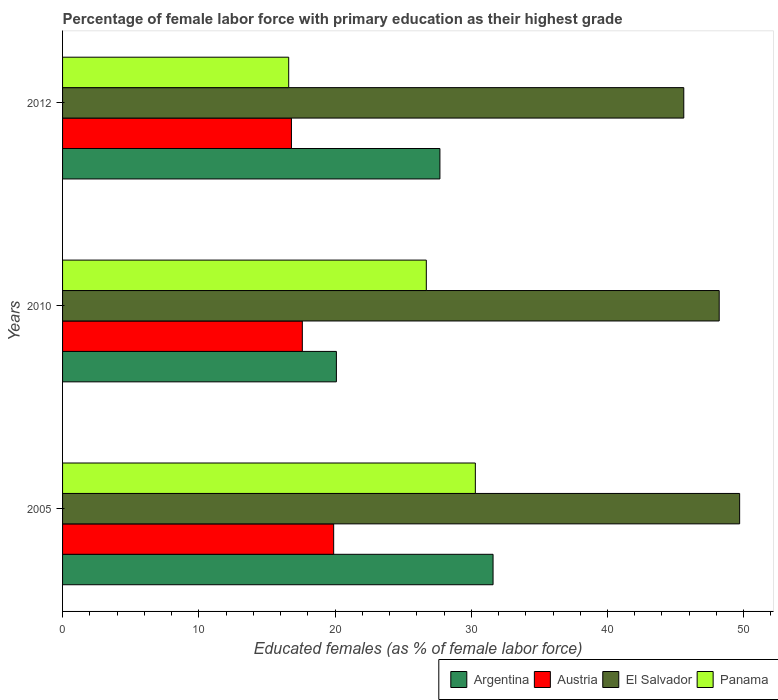How many different coloured bars are there?
Offer a terse response. 4. How many groups of bars are there?
Give a very brief answer. 3. Are the number of bars on each tick of the Y-axis equal?
Offer a terse response. Yes. How many bars are there on the 2nd tick from the top?
Ensure brevity in your answer.  4. What is the percentage of female labor force with primary education in Austria in 2012?
Offer a terse response. 16.8. Across all years, what is the maximum percentage of female labor force with primary education in Argentina?
Give a very brief answer. 31.6. Across all years, what is the minimum percentage of female labor force with primary education in Austria?
Make the answer very short. 16.8. In which year was the percentage of female labor force with primary education in Argentina minimum?
Provide a short and direct response. 2010. What is the total percentage of female labor force with primary education in Panama in the graph?
Provide a short and direct response. 73.6. What is the difference between the percentage of female labor force with primary education in Argentina in 2010 and that in 2012?
Offer a terse response. -7.6. What is the difference between the percentage of female labor force with primary education in Austria in 2010 and the percentage of female labor force with primary education in Panama in 2005?
Your answer should be very brief. -12.7. What is the average percentage of female labor force with primary education in Panama per year?
Give a very brief answer. 24.53. In the year 2012, what is the difference between the percentage of female labor force with primary education in El Salvador and percentage of female labor force with primary education in Austria?
Your answer should be compact. 28.8. What is the ratio of the percentage of female labor force with primary education in Panama in 2005 to that in 2012?
Your response must be concise. 1.83. What is the difference between the highest and the second highest percentage of female labor force with primary education in Austria?
Your response must be concise. 2.3. What is the difference between the highest and the lowest percentage of female labor force with primary education in El Salvador?
Keep it short and to the point. 4.1. Is the sum of the percentage of female labor force with primary education in El Salvador in 2005 and 2010 greater than the maximum percentage of female labor force with primary education in Argentina across all years?
Your answer should be compact. Yes. Is it the case that in every year, the sum of the percentage of female labor force with primary education in Argentina and percentage of female labor force with primary education in El Salvador is greater than the sum of percentage of female labor force with primary education in Austria and percentage of female labor force with primary education in Panama?
Provide a short and direct response. Yes. What does the 4th bar from the bottom in 2005 represents?
Provide a short and direct response. Panama. How many bars are there?
Your answer should be very brief. 12. Are all the bars in the graph horizontal?
Make the answer very short. Yes. Are the values on the major ticks of X-axis written in scientific E-notation?
Keep it short and to the point. No. Does the graph contain grids?
Give a very brief answer. No. How are the legend labels stacked?
Provide a succinct answer. Horizontal. What is the title of the graph?
Your response must be concise. Percentage of female labor force with primary education as their highest grade. Does "Fragile and conflict affected situations" appear as one of the legend labels in the graph?
Your answer should be very brief. No. What is the label or title of the X-axis?
Make the answer very short. Educated females (as % of female labor force). What is the label or title of the Y-axis?
Provide a short and direct response. Years. What is the Educated females (as % of female labor force) of Argentina in 2005?
Keep it short and to the point. 31.6. What is the Educated females (as % of female labor force) in Austria in 2005?
Provide a short and direct response. 19.9. What is the Educated females (as % of female labor force) in El Salvador in 2005?
Ensure brevity in your answer.  49.7. What is the Educated females (as % of female labor force) in Panama in 2005?
Give a very brief answer. 30.3. What is the Educated females (as % of female labor force) in Argentina in 2010?
Offer a terse response. 20.1. What is the Educated females (as % of female labor force) in Austria in 2010?
Your answer should be compact. 17.6. What is the Educated females (as % of female labor force) in El Salvador in 2010?
Provide a succinct answer. 48.2. What is the Educated females (as % of female labor force) in Panama in 2010?
Provide a short and direct response. 26.7. What is the Educated females (as % of female labor force) in Argentina in 2012?
Make the answer very short. 27.7. What is the Educated females (as % of female labor force) of Austria in 2012?
Offer a terse response. 16.8. What is the Educated females (as % of female labor force) of El Salvador in 2012?
Make the answer very short. 45.6. What is the Educated females (as % of female labor force) in Panama in 2012?
Your answer should be compact. 16.6. Across all years, what is the maximum Educated females (as % of female labor force) in Argentina?
Your response must be concise. 31.6. Across all years, what is the maximum Educated females (as % of female labor force) in Austria?
Offer a terse response. 19.9. Across all years, what is the maximum Educated females (as % of female labor force) of El Salvador?
Ensure brevity in your answer.  49.7. Across all years, what is the maximum Educated females (as % of female labor force) in Panama?
Offer a terse response. 30.3. Across all years, what is the minimum Educated females (as % of female labor force) of Argentina?
Keep it short and to the point. 20.1. Across all years, what is the minimum Educated females (as % of female labor force) in Austria?
Your response must be concise. 16.8. Across all years, what is the minimum Educated females (as % of female labor force) of El Salvador?
Give a very brief answer. 45.6. Across all years, what is the minimum Educated females (as % of female labor force) of Panama?
Offer a terse response. 16.6. What is the total Educated females (as % of female labor force) in Argentina in the graph?
Make the answer very short. 79.4. What is the total Educated females (as % of female labor force) of Austria in the graph?
Keep it short and to the point. 54.3. What is the total Educated females (as % of female labor force) in El Salvador in the graph?
Make the answer very short. 143.5. What is the total Educated females (as % of female labor force) of Panama in the graph?
Your answer should be very brief. 73.6. What is the difference between the Educated females (as % of female labor force) in Austria in 2005 and that in 2010?
Give a very brief answer. 2.3. What is the difference between the Educated females (as % of female labor force) in Argentina in 2005 and that in 2012?
Give a very brief answer. 3.9. What is the difference between the Educated females (as % of female labor force) of Austria in 2005 and that in 2012?
Offer a terse response. 3.1. What is the difference between the Educated females (as % of female labor force) in El Salvador in 2005 and that in 2012?
Offer a terse response. 4.1. What is the difference between the Educated females (as % of female labor force) of Panama in 2005 and that in 2012?
Ensure brevity in your answer.  13.7. What is the difference between the Educated females (as % of female labor force) in El Salvador in 2010 and that in 2012?
Keep it short and to the point. 2.6. What is the difference between the Educated females (as % of female labor force) of Panama in 2010 and that in 2012?
Make the answer very short. 10.1. What is the difference between the Educated females (as % of female labor force) of Argentina in 2005 and the Educated females (as % of female labor force) of Austria in 2010?
Ensure brevity in your answer.  14. What is the difference between the Educated females (as % of female labor force) in Argentina in 2005 and the Educated females (as % of female labor force) in El Salvador in 2010?
Offer a terse response. -16.6. What is the difference between the Educated females (as % of female labor force) of Argentina in 2005 and the Educated females (as % of female labor force) of Panama in 2010?
Your answer should be compact. 4.9. What is the difference between the Educated females (as % of female labor force) of Austria in 2005 and the Educated females (as % of female labor force) of El Salvador in 2010?
Provide a short and direct response. -28.3. What is the difference between the Educated females (as % of female labor force) in Austria in 2005 and the Educated females (as % of female labor force) in Panama in 2010?
Offer a terse response. -6.8. What is the difference between the Educated females (as % of female labor force) of Argentina in 2005 and the Educated females (as % of female labor force) of Austria in 2012?
Give a very brief answer. 14.8. What is the difference between the Educated females (as % of female labor force) in Argentina in 2005 and the Educated females (as % of female labor force) in El Salvador in 2012?
Make the answer very short. -14. What is the difference between the Educated females (as % of female labor force) in Austria in 2005 and the Educated females (as % of female labor force) in El Salvador in 2012?
Keep it short and to the point. -25.7. What is the difference between the Educated females (as % of female labor force) in Austria in 2005 and the Educated females (as % of female labor force) in Panama in 2012?
Give a very brief answer. 3.3. What is the difference between the Educated females (as % of female labor force) in El Salvador in 2005 and the Educated females (as % of female labor force) in Panama in 2012?
Ensure brevity in your answer.  33.1. What is the difference between the Educated females (as % of female labor force) in Argentina in 2010 and the Educated females (as % of female labor force) in El Salvador in 2012?
Offer a very short reply. -25.5. What is the difference between the Educated females (as % of female labor force) in Austria in 2010 and the Educated females (as % of female labor force) in Panama in 2012?
Make the answer very short. 1. What is the difference between the Educated females (as % of female labor force) of El Salvador in 2010 and the Educated females (as % of female labor force) of Panama in 2012?
Keep it short and to the point. 31.6. What is the average Educated females (as % of female labor force) in Argentina per year?
Your answer should be compact. 26.47. What is the average Educated females (as % of female labor force) in El Salvador per year?
Your answer should be compact. 47.83. What is the average Educated females (as % of female labor force) in Panama per year?
Your answer should be compact. 24.53. In the year 2005, what is the difference between the Educated females (as % of female labor force) in Argentina and Educated females (as % of female labor force) in El Salvador?
Keep it short and to the point. -18.1. In the year 2005, what is the difference between the Educated females (as % of female labor force) in Austria and Educated females (as % of female labor force) in El Salvador?
Offer a terse response. -29.8. In the year 2005, what is the difference between the Educated females (as % of female labor force) of El Salvador and Educated females (as % of female labor force) of Panama?
Keep it short and to the point. 19.4. In the year 2010, what is the difference between the Educated females (as % of female labor force) in Argentina and Educated females (as % of female labor force) in Austria?
Offer a terse response. 2.5. In the year 2010, what is the difference between the Educated females (as % of female labor force) of Argentina and Educated females (as % of female labor force) of El Salvador?
Offer a very short reply. -28.1. In the year 2010, what is the difference between the Educated females (as % of female labor force) in Austria and Educated females (as % of female labor force) in El Salvador?
Keep it short and to the point. -30.6. In the year 2010, what is the difference between the Educated females (as % of female labor force) in Austria and Educated females (as % of female labor force) in Panama?
Your response must be concise. -9.1. In the year 2010, what is the difference between the Educated females (as % of female labor force) of El Salvador and Educated females (as % of female labor force) of Panama?
Keep it short and to the point. 21.5. In the year 2012, what is the difference between the Educated females (as % of female labor force) in Argentina and Educated females (as % of female labor force) in El Salvador?
Your answer should be very brief. -17.9. In the year 2012, what is the difference between the Educated females (as % of female labor force) in Austria and Educated females (as % of female labor force) in El Salvador?
Provide a short and direct response. -28.8. What is the ratio of the Educated females (as % of female labor force) in Argentina in 2005 to that in 2010?
Your response must be concise. 1.57. What is the ratio of the Educated females (as % of female labor force) of Austria in 2005 to that in 2010?
Provide a short and direct response. 1.13. What is the ratio of the Educated females (as % of female labor force) in El Salvador in 2005 to that in 2010?
Make the answer very short. 1.03. What is the ratio of the Educated females (as % of female labor force) in Panama in 2005 to that in 2010?
Your answer should be compact. 1.13. What is the ratio of the Educated females (as % of female labor force) in Argentina in 2005 to that in 2012?
Your response must be concise. 1.14. What is the ratio of the Educated females (as % of female labor force) of Austria in 2005 to that in 2012?
Provide a short and direct response. 1.18. What is the ratio of the Educated females (as % of female labor force) of El Salvador in 2005 to that in 2012?
Keep it short and to the point. 1.09. What is the ratio of the Educated females (as % of female labor force) of Panama in 2005 to that in 2012?
Provide a short and direct response. 1.83. What is the ratio of the Educated females (as % of female labor force) in Argentina in 2010 to that in 2012?
Your response must be concise. 0.73. What is the ratio of the Educated females (as % of female labor force) of Austria in 2010 to that in 2012?
Provide a short and direct response. 1.05. What is the ratio of the Educated females (as % of female labor force) in El Salvador in 2010 to that in 2012?
Your answer should be very brief. 1.06. What is the ratio of the Educated females (as % of female labor force) in Panama in 2010 to that in 2012?
Provide a succinct answer. 1.61. What is the difference between the highest and the second highest Educated females (as % of female labor force) in Argentina?
Provide a succinct answer. 3.9. What is the difference between the highest and the second highest Educated females (as % of female labor force) in El Salvador?
Your answer should be very brief. 1.5. What is the difference between the highest and the second highest Educated females (as % of female labor force) in Panama?
Provide a succinct answer. 3.6. What is the difference between the highest and the lowest Educated females (as % of female labor force) of Argentina?
Provide a short and direct response. 11.5. What is the difference between the highest and the lowest Educated females (as % of female labor force) of Austria?
Provide a short and direct response. 3.1. What is the difference between the highest and the lowest Educated females (as % of female labor force) in El Salvador?
Provide a short and direct response. 4.1. 